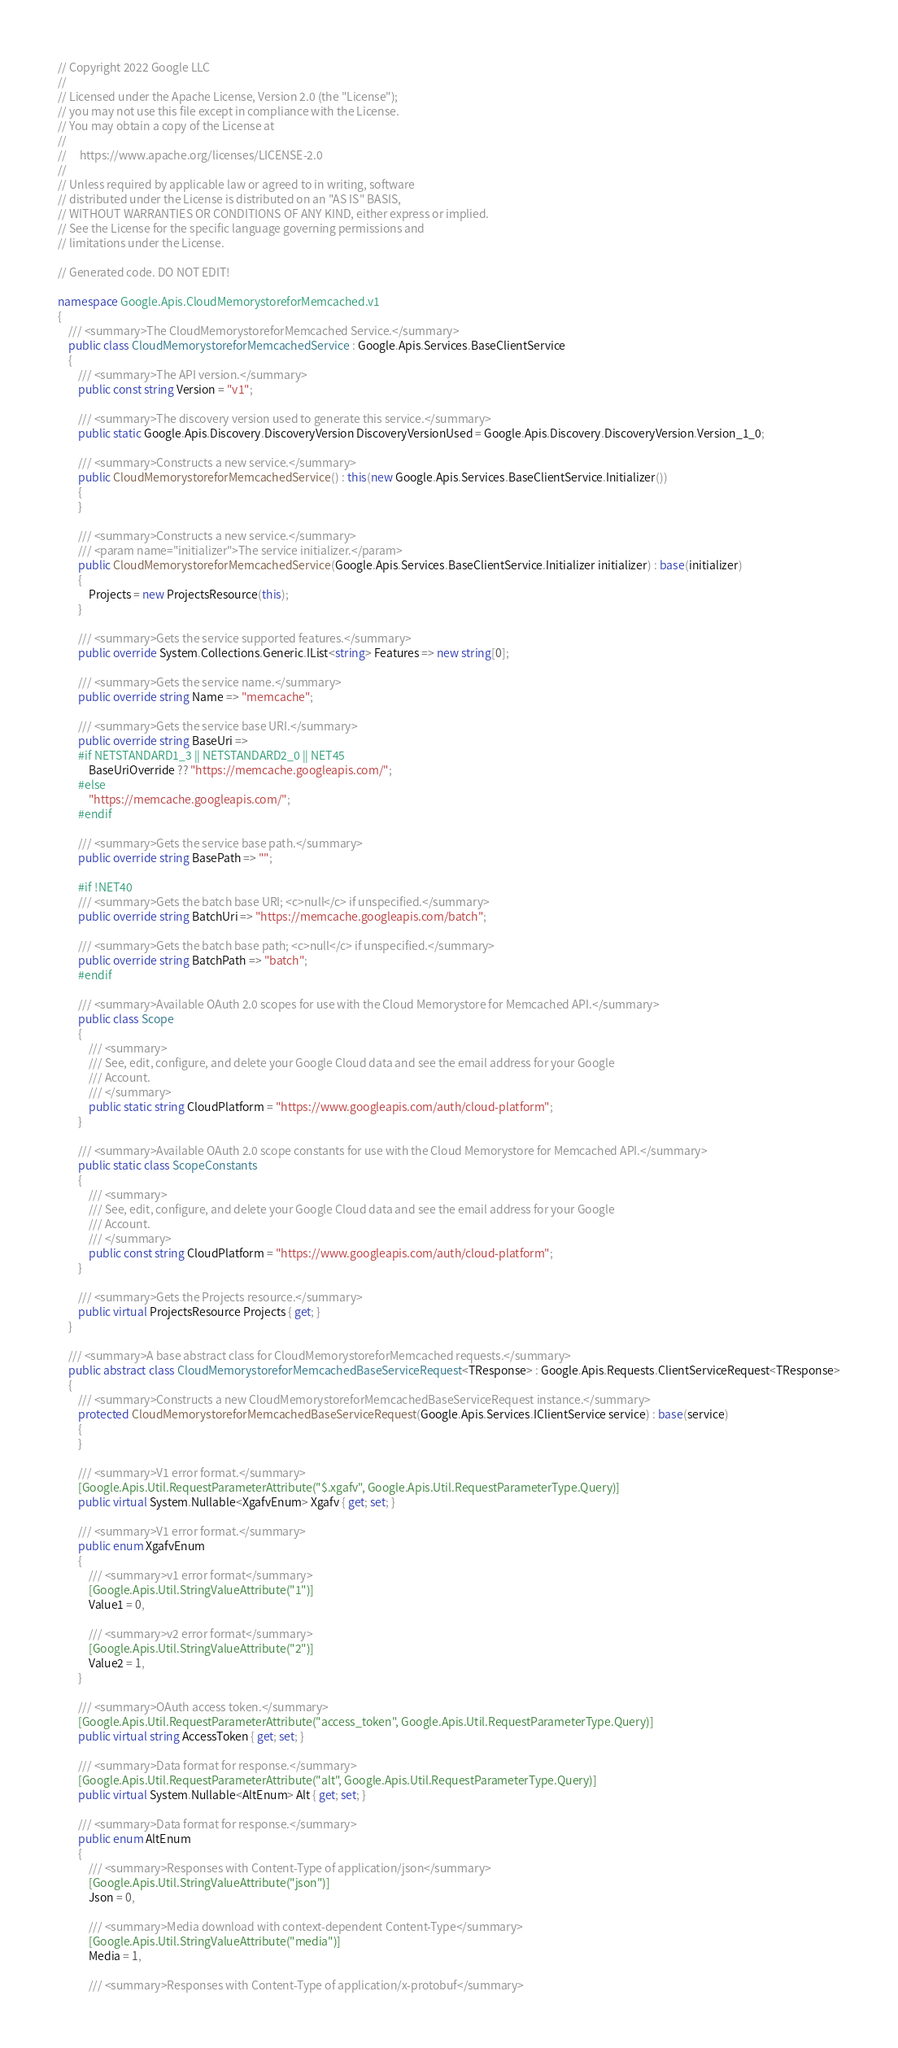Convert code to text. <code><loc_0><loc_0><loc_500><loc_500><_C#_>// Copyright 2022 Google LLC
//
// Licensed under the Apache License, Version 2.0 (the "License");
// you may not use this file except in compliance with the License.
// You may obtain a copy of the License at
//
//     https://www.apache.org/licenses/LICENSE-2.0
//
// Unless required by applicable law or agreed to in writing, software
// distributed under the License is distributed on an "AS IS" BASIS,
// WITHOUT WARRANTIES OR CONDITIONS OF ANY KIND, either express or implied.
// See the License for the specific language governing permissions and
// limitations under the License.

// Generated code. DO NOT EDIT!

namespace Google.Apis.CloudMemorystoreforMemcached.v1
{
    /// <summary>The CloudMemorystoreforMemcached Service.</summary>
    public class CloudMemorystoreforMemcachedService : Google.Apis.Services.BaseClientService
    {
        /// <summary>The API version.</summary>
        public const string Version = "v1";

        /// <summary>The discovery version used to generate this service.</summary>
        public static Google.Apis.Discovery.DiscoveryVersion DiscoveryVersionUsed = Google.Apis.Discovery.DiscoveryVersion.Version_1_0;

        /// <summary>Constructs a new service.</summary>
        public CloudMemorystoreforMemcachedService() : this(new Google.Apis.Services.BaseClientService.Initializer())
        {
        }

        /// <summary>Constructs a new service.</summary>
        /// <param name="initializer">The service initializer.</param>
        public CloudMemorystoreforMemcachedService(Google.Apis.Services.BaseClientService.Initializer initializer) : base(initializer)
        {
            Projects = new ProjectsResource(this);
        }

        /// <summary>Gets the service supported features.</summary>
        public override System.Collections.Generic.IList<string> Features => new string[0];

        /// <summary>Gets the service name.</summary>
        public override string Name => "memcache";

        /// <summary>Gets the service base URI.</summary>
        public override string BaseUri =>
        #if NETSTANDARD1_3 || NETSTANDARD2_0 || NET45
            BaseUriOverride ?? "https://memcache.googleapis.com/";
        #else
            "https://memcache.googleapis.com/";
        #endif

        /// <summary>Gets the service base path.</summary>
        public override string BasePath => "";

        #if !NET40
        /// <summary>Gets the batch base URI; <c>null</c> if unspecified.</summary>
        public override string BatchUri => "https://memcache.googleapis.com/batch";

        /// <summary>Gets the batch base path; <c>null</c> if unspecified.</summary>
        public override string BatchPath => "batch";
        #endif

        /// <summary>Available OAuth 2.0 scopes for use with the Cloud Memorystore for Memcached API.</summary>
        public class Scope
        {
            /// <summary>
            /// See, edit, configure, and delete your Google Cloud data and see the email address for your Google
            /// Account.
            /// </summary>
            public static string CloudPlatform = "https://www.googleapis.com/auth/cloud-platform";
        }

        /// <summary>Available OAuth 2.0 scope constants for use with the Cloud Memorystore for Memcached API.</summary>
        public static class ScopeConstants
        {
            /// <summary>
            /// See, edit, configure, and delete your Google Cloud data and see the email address for your Google
            /// Account.
            /// </summary>
            public const string CloudPlatform = "https://www.googleapis.com/auth/cloud-platform";
        }

        /// <summary>Gets the Projects resource.</summary>
        public virtual ProjectsResource Projects { get; }
    }

    /// <summary>A base abstract class for CloudMemorystoreforMemcached requests.</summary>
    public abstract class CloudMemorystoreforMemcachedBaseServiceRequest<TResponse> : Google.Apis.Requests.ClientServiceRequest<TResponse>
    {
        /// <summary>Constructs a new CloudMemorystoreforMemcachedBaseServiceRequest instance.</summary>
        protected CloudMemorystoreforMemcachedBaseServiceRequest(Google.Apis.Services.IClientService service) : base(service)
        {
        }

        /// <summary>V1 error format.</summary>
        [Google.Apis.Util.RequestParameterAttribute("$.xgafv", Google.Apis.Util.RequestParameterType.Query)]
        public virtual System.Nullable<XgafvEnum> Xgafv { get; set; }

        /// <summary>V1 error format.</summary>
        public enum XgafvEnum
        {
            /// <summary>v1 error format</summary>
            [Google.Apis.Util.StringValueAttribute("1")]
            Value1 = 0,

            /// <summary>v2 error format</summary>
            [Google.Apis.Util.StringValueAttribute("2")]
            Value2 = 1,
        }

        /// <summary>OAuth access token.</summary>
        [Google.Apis.Util.RequestParameterAttribute("access_token", Google.Apis.Util.RequestParameterType.Query)]
        public virtual string AccessToken { get; set; }

        /// <summary>Data format for response.</summary>
        [Google.Apis.Util.RequestParameterAttribute("alt", Google.Apis.Util.RequestParameterType.Query)]
        public virtual System.Nullable<AltEnum> Alt { get; set; }

        /// <summary>Data format for response.</summary>
        public enum AltEnum
        {
            /// <summary>Responses with Content-Type of application/json</summary>
            [Google.Apis.Util.StringValueAttribute("json")]
            Json = 0,

            /// <summary>Media download with context-dependent Content-Type</summary>
            [Google.Apis.Util.StringValueAttribute("media")]
            Media = 1,

            /// <summary>Responses with Content-Type of application/x-protobuf</summary></code> 